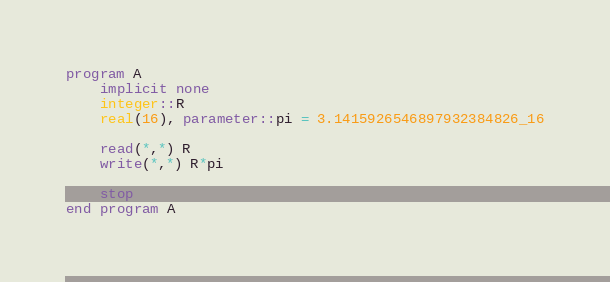<code> <loc_0><loc_0><loc_500><loc_500><_FORTRAN_>program A
    implicit none
    integer::R
    real(16), parameter::pi = 3.1415926546897932384826_16

    read(*,*) R
    write(*,*) R*pi

    stop
end program A</code> 